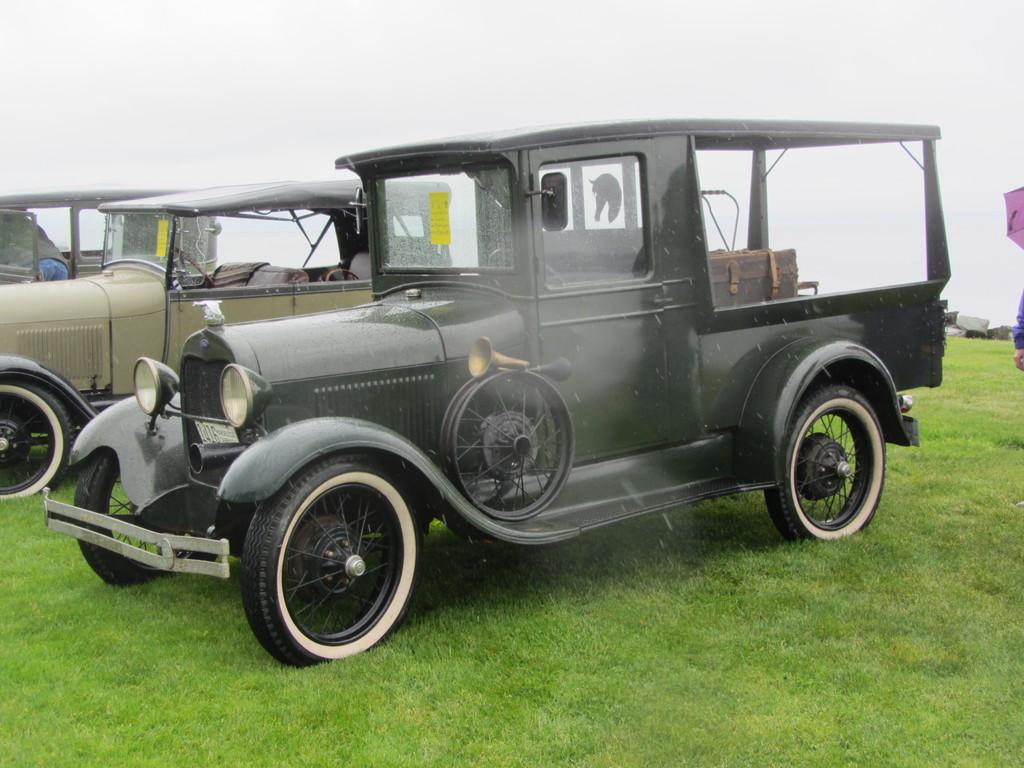What type of vehicles can be seen in the image? There are cars in the image. How would you describe the weather based on the image? The sky is cloudy in the image. Can you identify any people in the image? Yes, there is a human standing on the side in the image. What object might be used for protection from the weather in the image? There is an umbrella in the image. What type of surface is visible on the ground in the image? Grass is present on the ground in the image. Where is the jail located in the image? There is no jail present in the image. What type of knife is being used by the person in the image? There is no knife present in the image. 